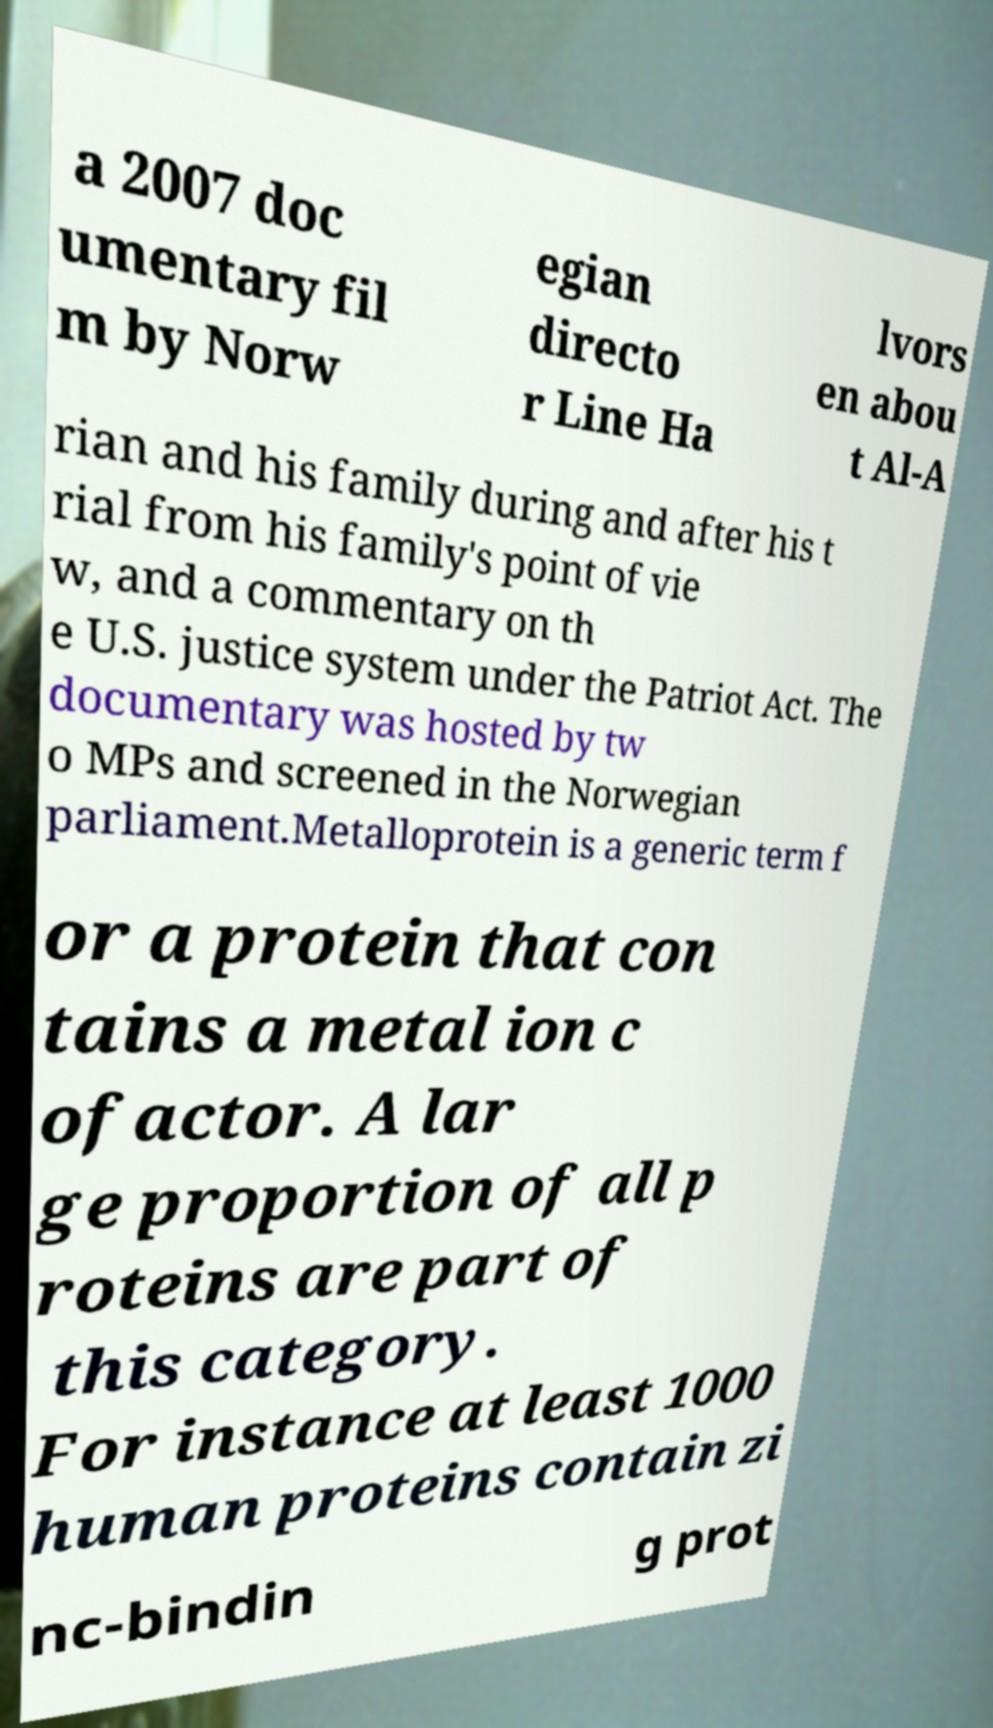Can you read and provide the text displayed in the image?This photo seems to have some interesting text. Can you extract and type it out for me? a 2007 doc umentary fil m by Norw egian directo r Line Ha lvors en abou t Al-A rian and his family during and after his t rial from his family's point of vie w, and a commentary on th e U.S. justice system under the Patriot Act. The documentary was hosted by tw o MPs and screened in the Norwegian parliament.Metalloprotein is a generic term f or a protein that con tains a metal ion c ofactor. A lar ge proportion of all p roteins are part of this category. For instance at least 1000 human proteins contain zi nc-bindin g prot 